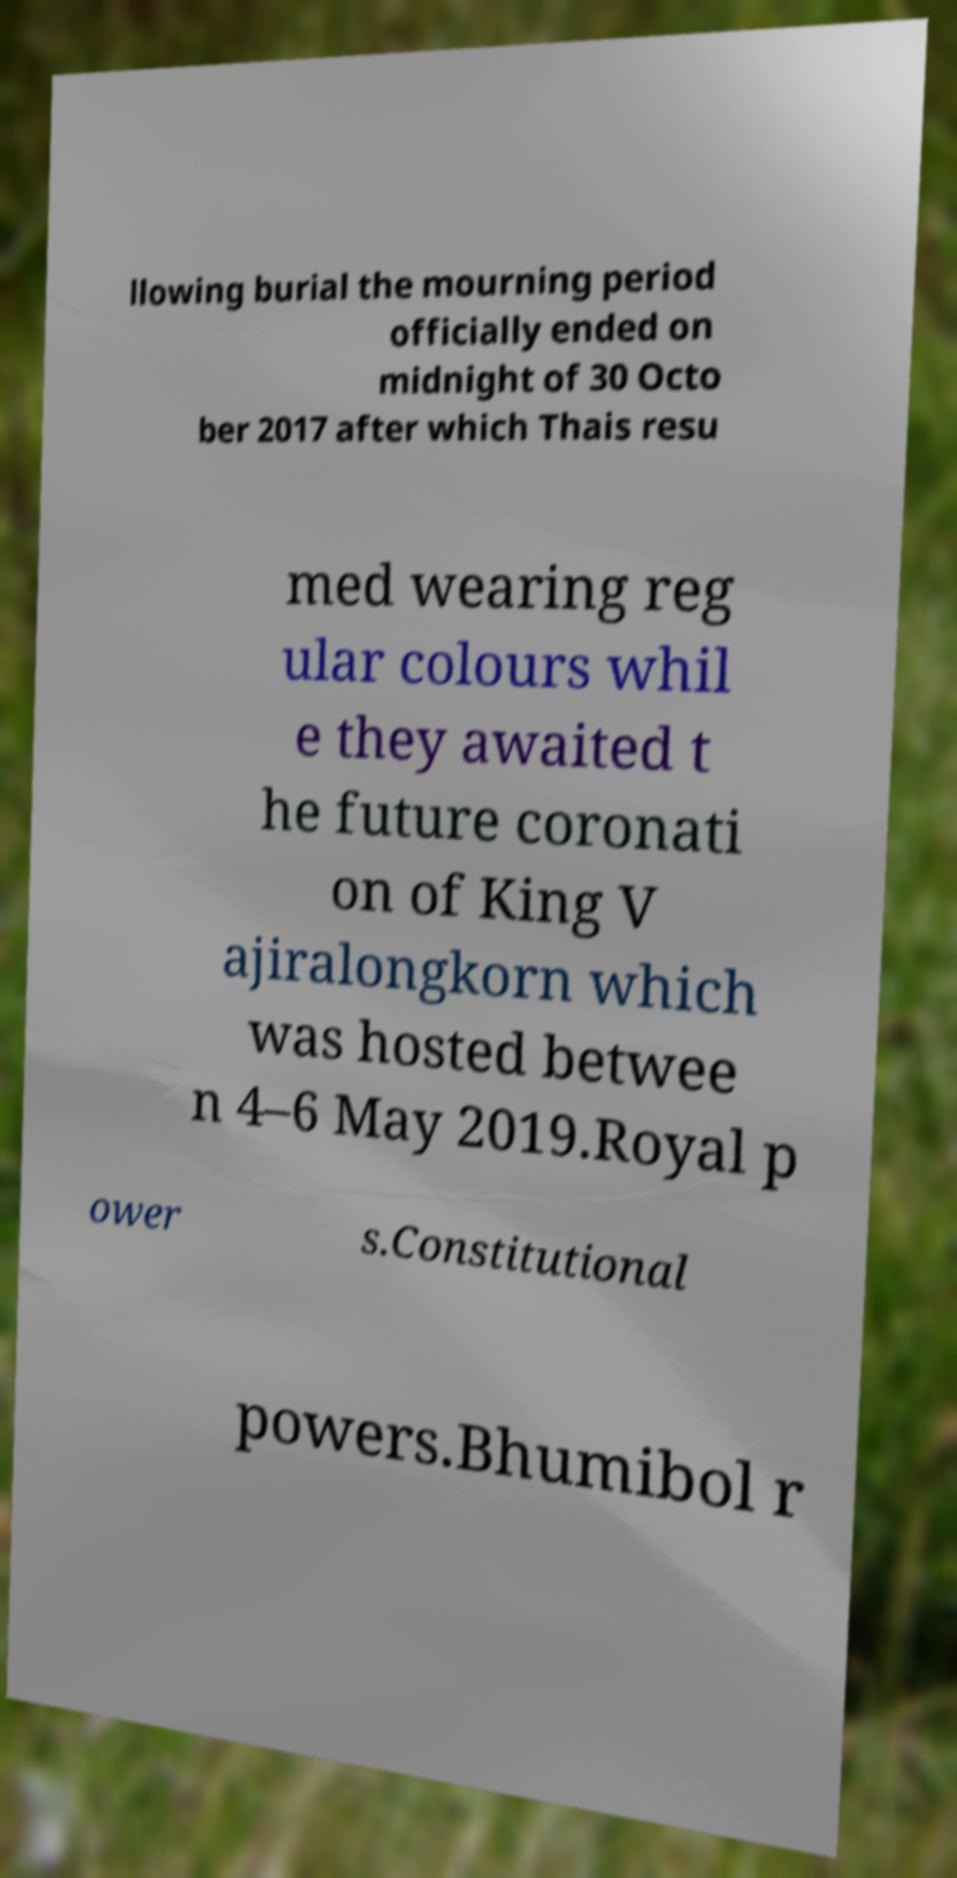Can you read and provide the text displayed in the image?This photo seems to have some interesting text. Can you extract and type it out for me? llowing burial the mourning period officially ended on midnight of 30 Octo ber 2017 after which Thais resu med wearing reg ular colours whil e they awaited t he future coronati on of King V ajiralongkorn which was hosted betwee n 4–6 May 2019.Royal p ower s.Constitutional powers.Bhumibol r 